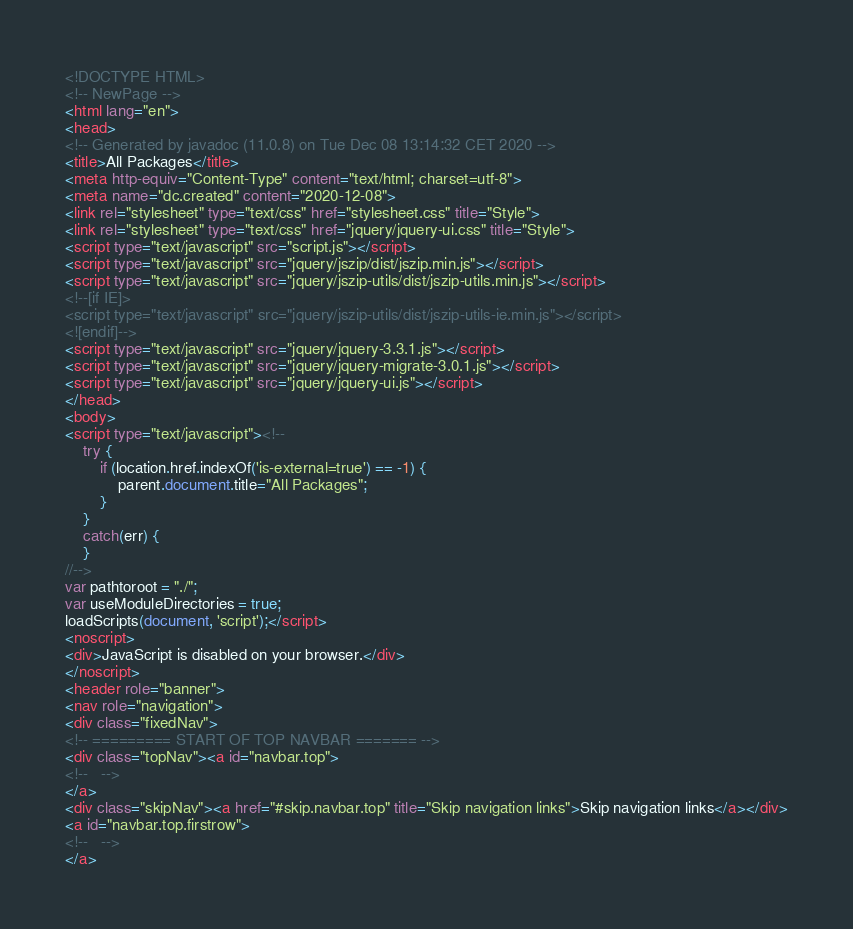Convert code to text. <code><loc_0><loc_0><loc_500><loc_500><_HTML_><!DOCTYPE HTML>
<!-- NewPage -->
<html lang="en">
<head>
<!-- Generated by javadoc (11.0.8) on Tue Dec 08 13:14:32 CET 2020 -->
<title>All Packages</title>
<meta http-equiv="Content-Type" content="text/html; charset=utf-8">
<meta name="dc.created" content="2020-12-08">
<link rel="stylesheet" type="text/css" href="stylesheet.css" title="Style">
<link rel="stylesheet" type="text/css" href="jquery/jquery-ui.css" title="Style">
<script type="text/javascript" src="script.js"></script>
<script type="text/javascript" src="jquery/jszip/dist/jszip.min.js"></script>
<script type="text/javascript" src="jquery/jszip-utils/dist/jszip-utils.min.js"></script>
<!--[if IE]>
<script type="text/javascript" src="jquery/jszip-utils/dist/jszip-utils-ie.min.js"></script>
<![endif]-->
<script type="text/javascript" src="jquery/jquery-3.3.1.js"></script>
<script type="text/javascript" src="jquery/jquery-migrate-3.0.1.js"></script>
<script type="text/javascript" src="jquery/jquery-ui.js"></script>
</head>
<body>
<script type="text/javascript"><!--
    try {
        if (location.href.indexOf('is-external=true') == -1) {
            parent.document.title="All Packages";
        }
    }
    catch(err) {
    }
//-->
var pathtoroot = "./";
var useModuleDirectories = true;
loadScripts(document, 'script');</script>
<noscript>
<div>JavaScript is disabled on your browser.</div>
</noscript>
<header role="banner">
<nav role="navigation">
<div class="fixedNav">
<!-- ========= START OF TOP NAVBAR ======= -->
<div class="topNav"><a id="navbar.top">
<!--   -->
</a>
<div class="skipNav"><a href="#skip.navbar.top" title="Skip navigation links">Skip navigation links</a></div>
<a id="navbar.top.firstrow">
<!--   -->
</a></code> 